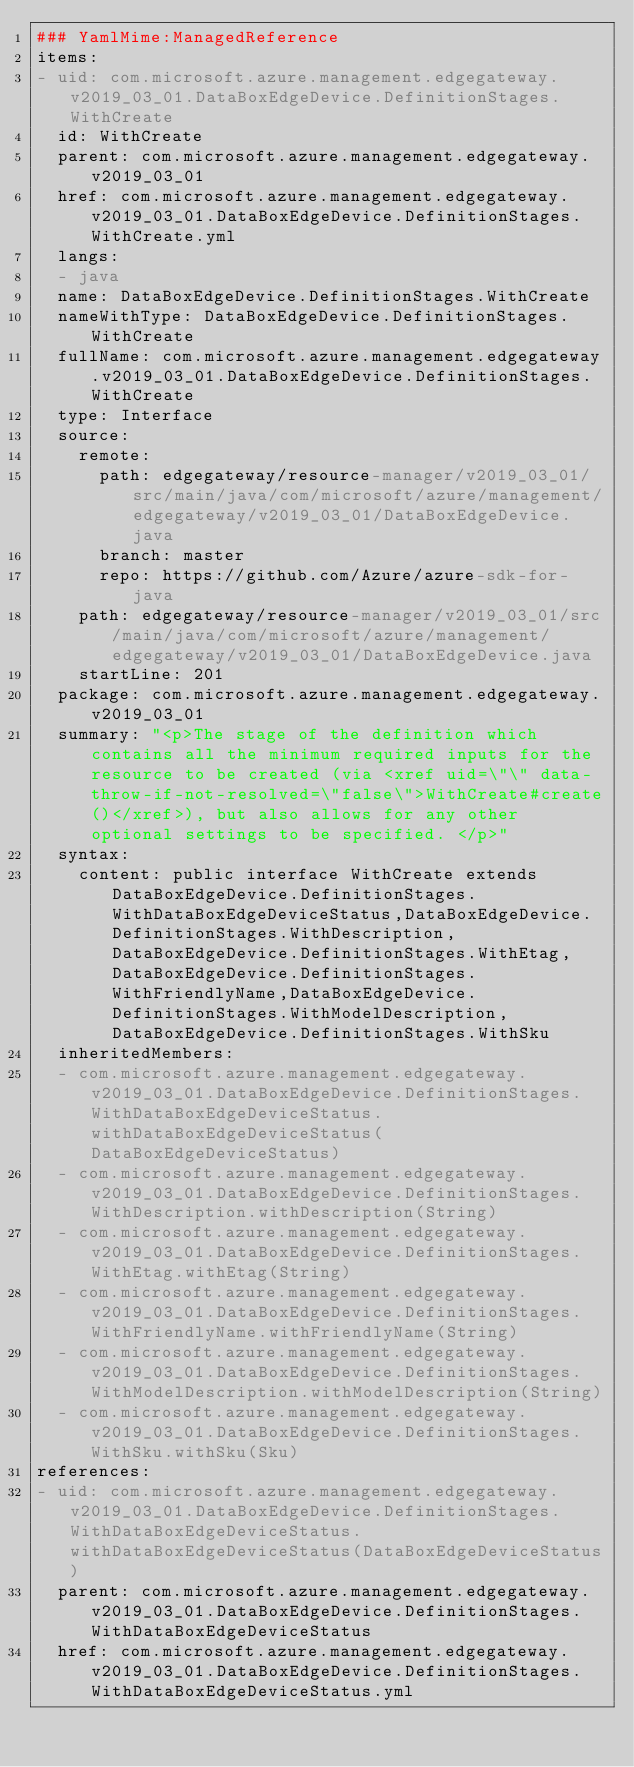Convert code to text. <code><loc_0><loc_0><loc_500><loc_500><_YAML_>### YamlMime:ManagedReference
items:
- uid: com.microsoft.azure.management.edgegateway.v2019_03_01.DataBoxEdgeDevice.DefinitionStages.WithCreate
  id: WithCreate
  parent: com.microsoft.azure.management.edgegateway.v2019_03_01
  href: com.microsoft.azure.management.edgegateway.v2019_03_01.DataBoxEdgeDevice.DefinitionStages.WithCreate.yml
  langs:
  - java
  name: DataBoxEdgeDevice.DefinitionStages.WithCreate
  nameWithType: DataBoxEdgeDevice.DefinitionStages.WithCreate
  fullName: com.microsoft.azure.management.edgegateway.v2019_03_01.DataBoxEdgeDevice.DefinitionStages.WithCreate
  type: Interface
  source:
    remote:
      path: edgegateway/resource-manager/v2019_03_01/src/main/java/com/microsoft/azure/management/edgegateway/v2019_03_01/DataBoxEdgeDevice.java
      branch: master
      repo: https://github.com/Azure/azure-sdk-for-java
    path: edgegateway/resource-manager/v2019_03_01/src/main/java/com/microsoft/azure/management/edgegateway/v2019_03_01/DataBoxEdgeDevice.java
    startLine: 201
  package: com.microsoft.azure.management.edgegateway.v2019_03_01
  summary: "<p>The stage of the definition which contains all the minimum required inputs for the resource to be created (via <xref uid=\"\" data-throw-if-not-resolved=\"false\">WithCreate#create()</xref>), but also allows for any other optional settings to be specified. </p>"
  syntax:
    content: public interface WithCreate extends DataBoxEdgeDevice.DefinitionStages.WithDataBoxEdgeDeviceStatus,DataBoxEdgeDevice.DefinitionStages.WithDescription,DataBoxEdgeDevice.DefinitionStages.WithEtag,DataBoxEdgeDevice.DefinitionStages.WithFriendlyName,DataBoxEdgeDevice.DefinitionStages.WithModelDescription,DataBoxEdgeDevice.DefinitionStages.WithSku
  inheritedMembers:
  - com.microsoft.azure.management.edgegateway.v2019_03_01.DataBoxEdgeDevice.DefinitionStages.WithDataBoxEdgeDeviceStatus.withDataBoxEdgeDeviceStatus(DataBoxEdgeDeviceStatus)
  - com.microsoft.azure.management.edgegateway.v2019_03_01.DataBoxEdgeDevice.DefinitionStages.WithDescription.withDescription(String)
  - com.microsoft.azure.management.edgegateway.v2019_03_01.DataBoxEdgeDevice.DefinitionStages.WithEtag.withEtag(String)
  - com.microsoft.azure.management.edgegateway.v2019_03_01.DataBoxEdgeDevice.DefinitionStages.WithFriendlyName.withFriendlyName(String)
  - com.microsoft.azure.management.edgegateway.v2019_03_01.DataBoxEdgeDevice.DefinitionStages.WithModelDescription.withModelDescription(String)
  - com.microsoft.azure.management.edgegateway.v2019_03_01.DataBoxEdgeDevice.DefinitionStages.WithSku.withSku(Sku)
references:
- uid: com.microsoft.azure.management.edgegateway.v2019_03_01.DataBoxEdgeDevice.DefinitionStages.WithDataBoxEdgeDeviceStatus.withDataBoxEdgeDeviceStatus(DataBoxEdgeDeviceStatus)
  parent: com.microsoft.azure.management.edgegateway.v2019_03_01.DataBoxEdgeDevice.DefinitionStages.WithDataBoxEdgeDeviceStatus
  href: com.microsoft.azure.management.edgegateway.v2019_03_01.DataBoxEdgeDevice.DefinitionStages.WithDataBoxEdgeDeviceStatus.yml</code> 